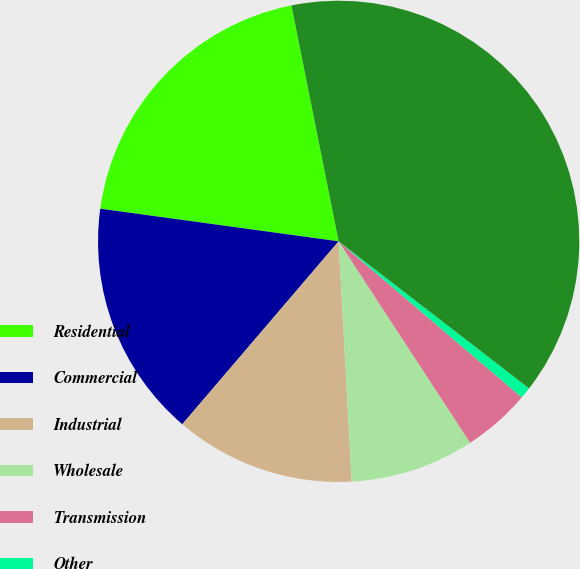Convert chart to OTSL. <chart><loc_0><loc_0><loc_500><loc_500><pie_chart><fcel>Residential<fcel>Commercial<fcel>Industrial<fcel>Wholesale<fcel>Transmission<fcel>Other<fcel>Total<nl><fcel>19.69%<fcel>15.91%<fcel>12.12%<fcel>8.34%<fcel>4.56%<fcel>0.77%<fcel>38.61%<nl></chart> 